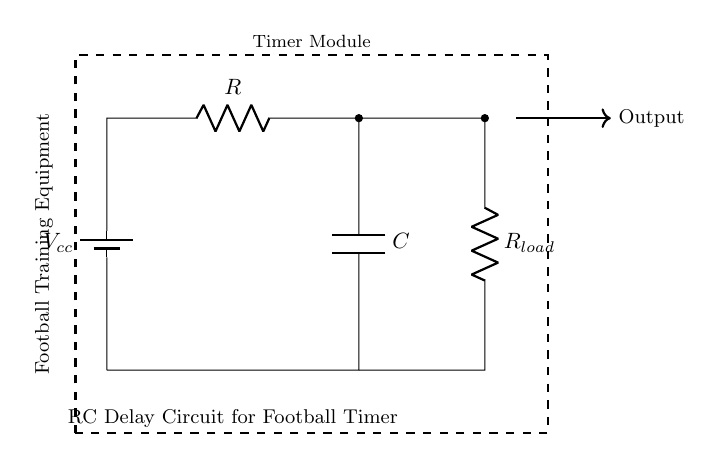What type of circuit is shown? The circuit shown is an RC delay circuit, which utilizes a resistor and a capacitor to create a delay in the output signal. The presence of a resistor and capacitor connected in series confirms this classification.
Answer: RC delay circuit What components are present in the circuit? The components present in the circuit are a resistor, a capacitor, a load resistor, and a battery. The diagram labels these components, making them easily identifiable.
Answer: Resistor, Capacitor, Load Resistor, Battery What is the purpose of the capacitor in this circuit? The capacitor in the RC delay circuit stores electrical energy and releases it slowly, creating a time delay in the output signal when the circuit is activated. Its function is to determine the timing characteristics of the circuit.
Answer: Store energy What happens when the battery is connected to the circuit? When the battery is connected, it supplies voltage to the circuit. The capacitor begins to charge through the resistor, leading to a gradual increase in voltage across the capacitor until it reaches near the battery voltage.
Answer: Voltage increases What is the effect of increasing the resistance value on the delay time? Increasing the resistance value will result in a longer delay time. This occurs because a higher resistance slows down the rate at which the capacitor charges, resulting in a more gradual rise in voltage across the capacitor and, hence, a delayed output.
Answer: Longer delay How does the load resistor affect the circuit's output? The load resistor affects the output by providing a path for the discharge of the capacitor. Depending on its value, it can influence the time constant of the circuit, which is critical for determining how quickly the circuit responds to changes when the timer is active.
Answer: Influences discharge 